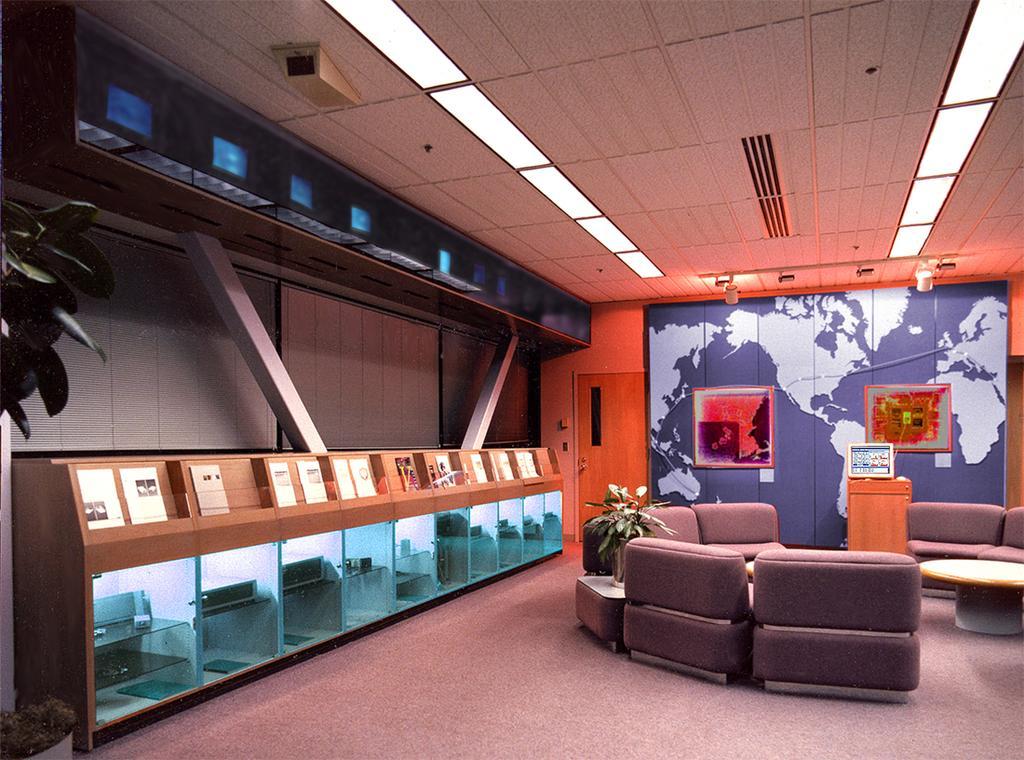In one or two sentences, can you explain what this image depicts? There are sofas and this is plant. Here we can see a table. In the background there is a wall and these are the frames. This is floor. And these are the lights and this is roof. Here we can see a table and these are the glasses. 